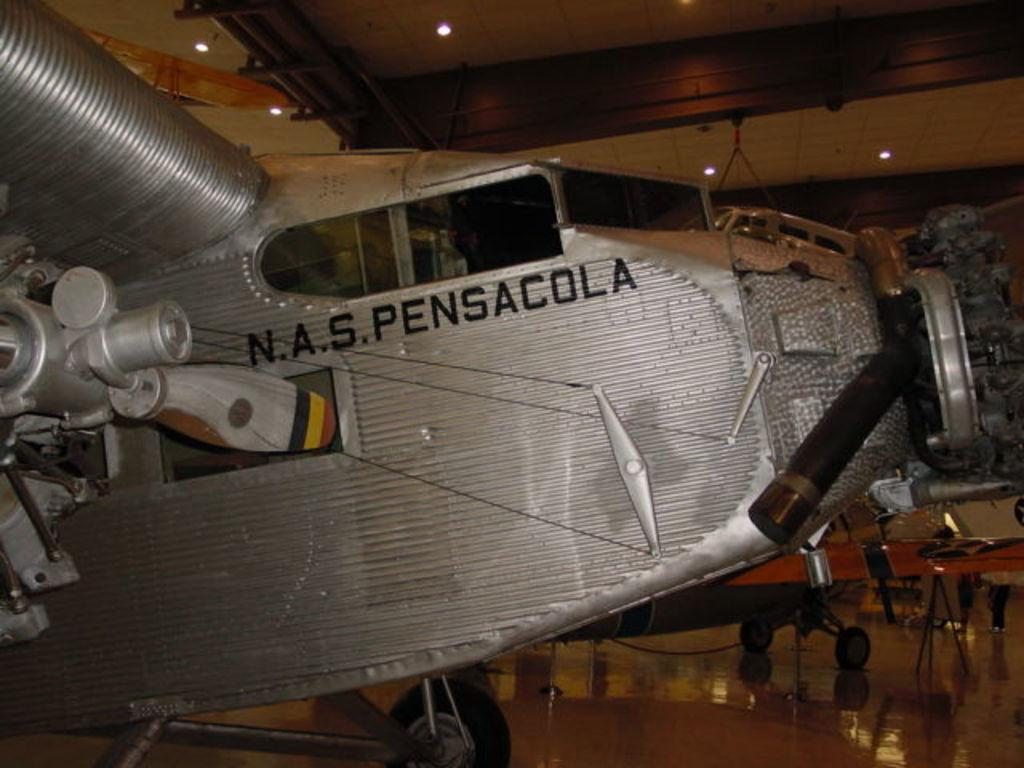What is the color of the object in the image? The object in the image is silver-colored. What other features can be seen in the image? There are two black-colored wheels in the image. What type of notebook is being used during the meeting in the image? There is no notebook or meeting present in the image; it only features a silver-colored object and two black-colored wheels. 